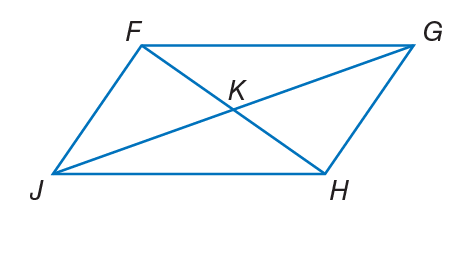Answer the mathemtical geometry problem and directly provide the correct option letter.
Question: If F K = 3 x - 1, K G = 4 y + 3, J K = 6 y - 2, and K H = 2 x + 3, find y so that the quadrilateral is a parallelogram.
Choices: A: 1 B: 2.5 C: 3 D: 5 B 